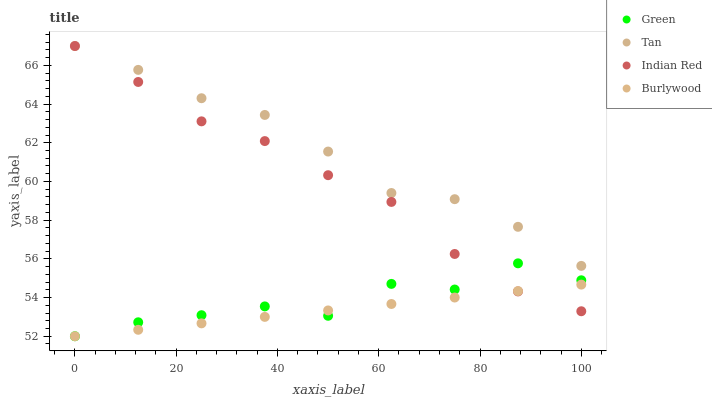Does Burlywood have the minimum area under the curve?
Answer yes or no. Yes. Does Tan have the maximum area under the curve?
Answer yes or no. Yes. Does Green have the minimum area under the curve?
Answer yes or no. No. Does Green have the maximum area under the curve?
Answer yes or no. No. Is Burlywood the smoothest?
Answer yes or no. Yes. Is Green the roughest?
Answer yes or no. Yes. Is Tan the smoothest?
Answer yes or no. No. Is Tan the roughest?
Answer yes or no. No. Does Burlywood have the lowest value?
Answer yes or no. Yes. Does Tan have the lowest value?
Answer yes or no. No. Does Indian Red have the highest value?
Answer yes or no. Yes. Does Green have the highest value?
Answer yes or no. No. Is Burlywood less than Tan?
Answer yes or no. Yes. Is Tan greater than Green?
Answer yes or no. Yes. Does Green intersect Burlywood?
Answer yes or no. Yes. Is Green less than Burlywood?
Answer yes or no. No. Is Green greater than Burlywood?
Answer yes or no. No. Does Burlywood intersect Tan?
Answer yes or no. No. 